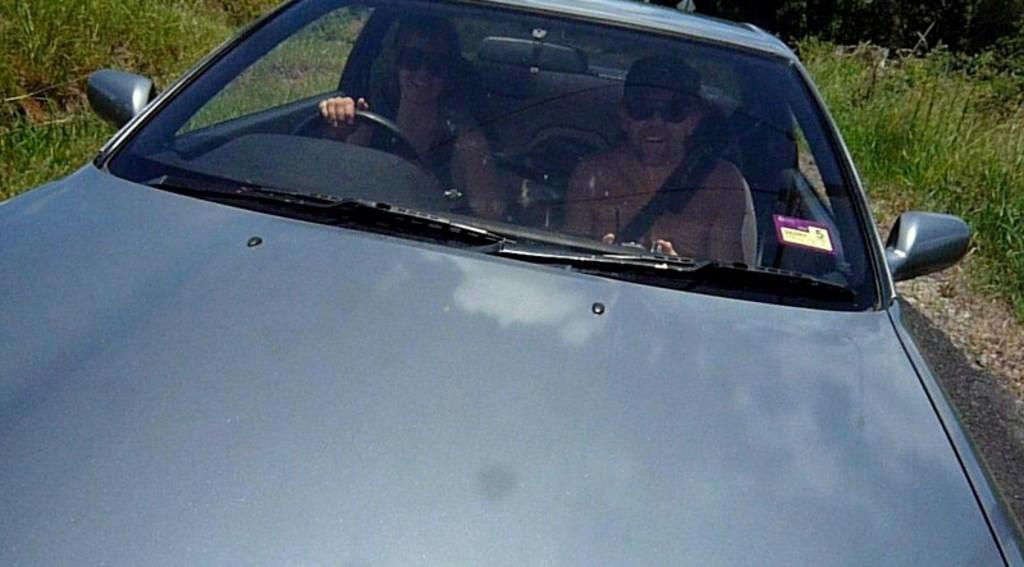What is the main subject of the image? There is a vehicle in the image. Who is inside the vehicle? There are two people sitting in the vehicle. What are the people wearing? The people are wearing clothes and goggles. What part of the vehicle can be seen in the image? There is a steering part visible in the image. What type of environment is visible in the image? There is grass visible in the image. Can you tell me how many fish are mentioned in the image? There are no fish present in the image; it features a vehicle with two people inside. 